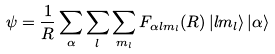<formula> <loc_0><loc_0><loc_500><loc_500>\psi = \frac { 1 } { R } \sum _ { \alpha } \sum _ { l } \sum _ { m _ { l } } F _ { \alpha l m _ { l } } ( R ) \, | l m _ { l } \rangle \, | \alpha \rangle</formula> 